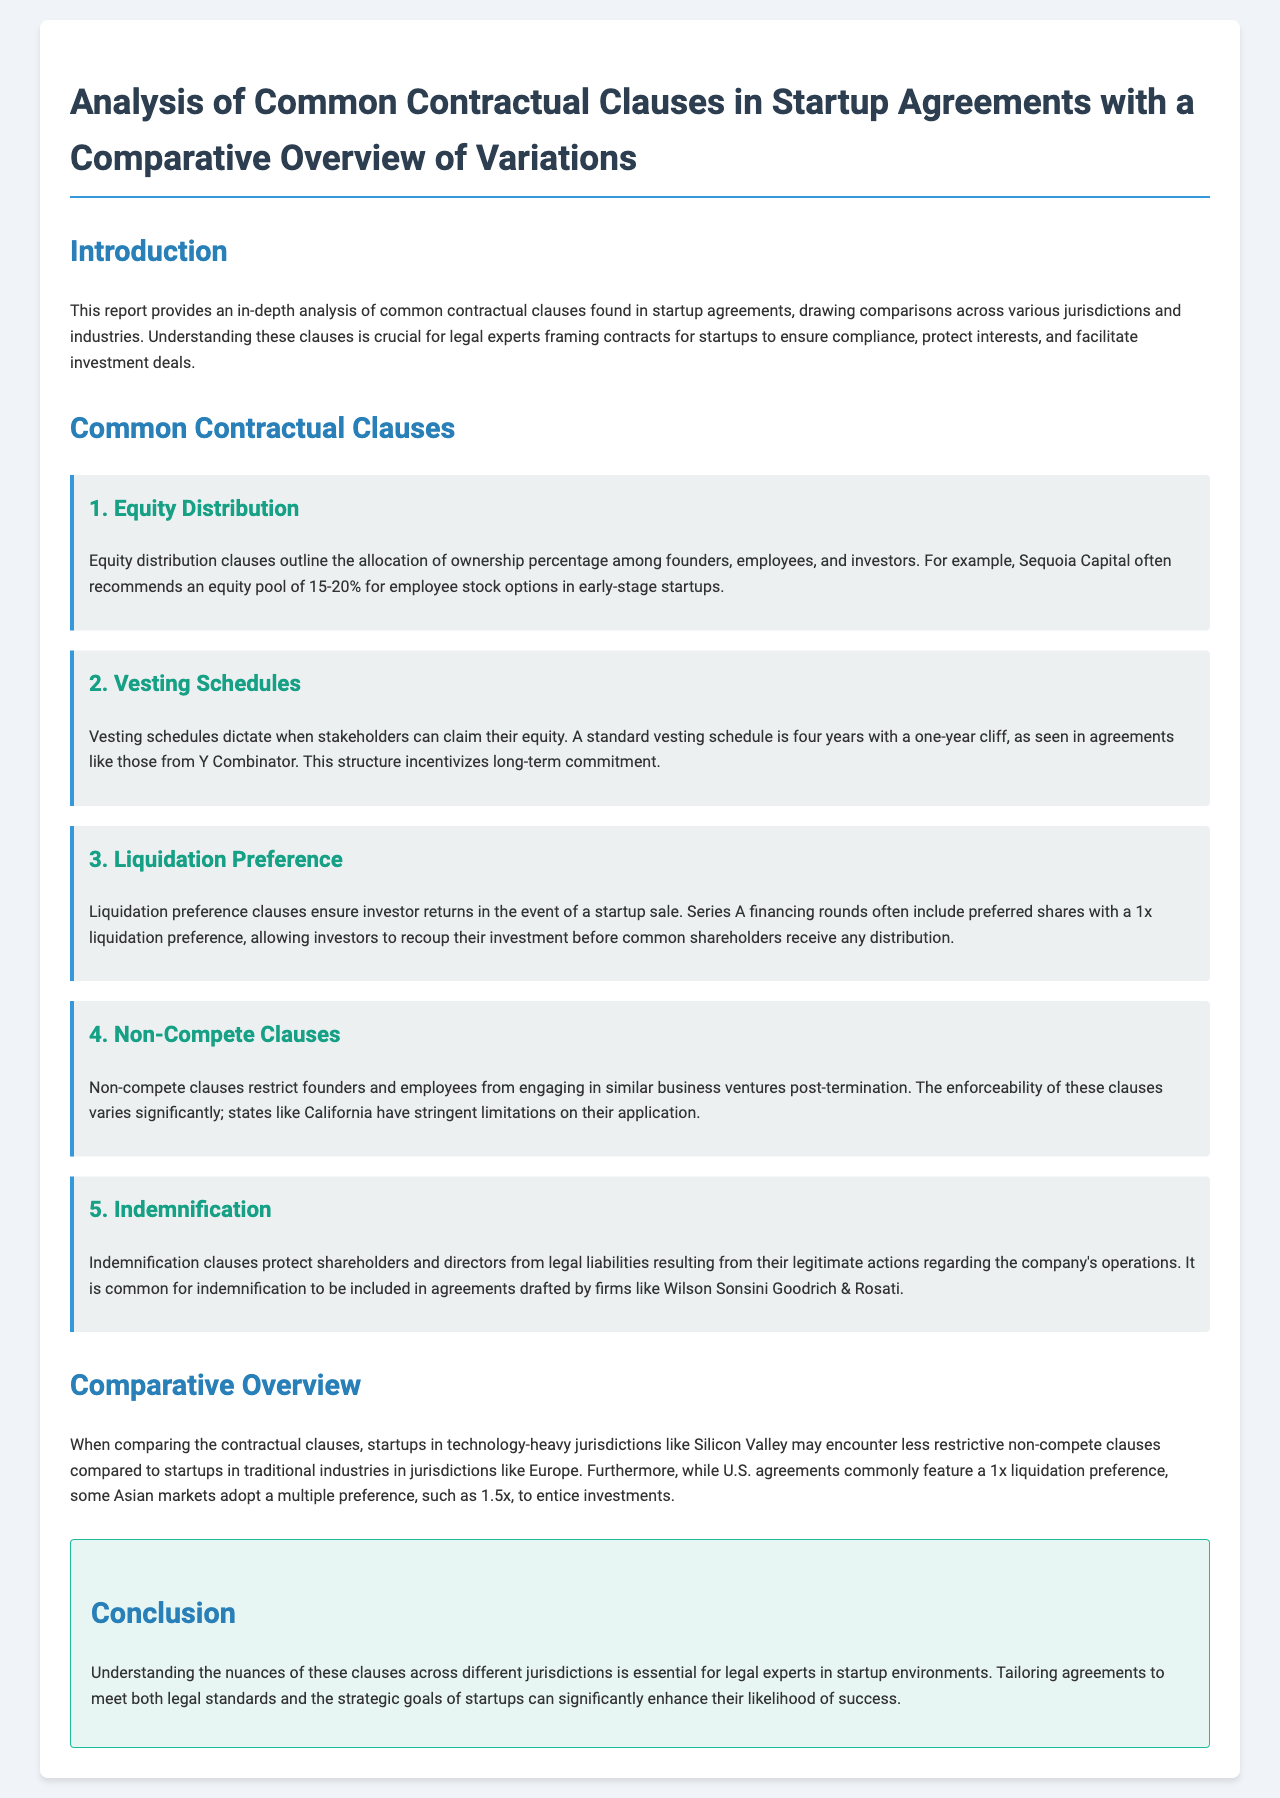What is the equity pool percentage recommended by Sequoia Capital for employee stock options? The report states that Sequoia Capital often recommends an equity pool of 15-20% for employee stock options in early-stage startups.
Answer: 15-20% What is the standard vesting schedule commonly used in agreements by Y Combinator? It mentions that a standard vesting schedule is four years with a one-year cliff as seen in agreements from Y Combinator.
Answer: Four years with a one-year cliff What is the typical liquidation preference included in Series A financing rounds? The document describes that Series A financing rounds often include preferred shares with a 1x liquidation preference.
Answer: 1x Which state is noted for having stringent limitations on non-compete clause enforceability? The report highlights that California has stringent limitations on the enforcement of non-compete clauses.
Answer: California What is the primary purpose of indemnification clauses in startup agreements? The report explains that indemnification clauses protect shareholders and directors from legal liabilities.
Answer: Protect legal liabilities How do non-compete clauses differ between technology-heavy jurisdictions and traditional industries? It notes that startups in technology-heavy jurisdictions like Silicon Valley may encounter less restrictive non-compete clauses compared to traditional industries in jurisdictions like Europe.
Answer: Less restrictive in technology-heavy jurisdictions What multiple does some Asian markets adopt for liquidation preference to entice investments? The report states that some Asian markets adopt a multiple preference, such as 1.5x, to attract investments.
Answer: 1.5x What is the significance of understanding contractual clause variations for legal experts? The conclusion emphasizes that understanding these clauses' nuances across different jurisdictions is essential for legal experts.
Answer: Essential for legal experts What role do firms like Wilson Sonsini Goodrich & Rosati play in indemnification clauses? The document indicates that it is common for indemnification to be included in agreements drafted by firms like Wilson Sonsini Goodrich & Rosati.
Answer: Drafting agreements 